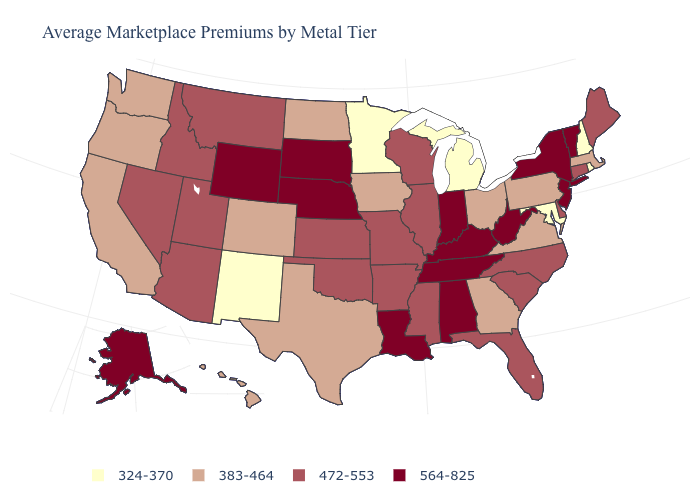Which states have the lowest value in the West?
Be succinct. New Mexico. Name the states that have a value in the range 383-464?
Short answer required. California, Colorado, Georgia, Hawaii, Iowa, Massachusetts, North Dakota, Ohio, Oregon, Pennsylvania, Texas, Virginia, Washington. Name the states that have a value in the range 383-464?
Give a very brief answer. California, Colorado, Georgia, Hawaii, Iowa, Massachusetts, North Dakota, Ohio, Oregon, Pennsylvania, Texas, Virginia, Washington. What is the value of Delaware?
Short answer required. 472-553. Name the states that have a value in the range 472-553?
Write a very short answer. Arizona, Arkansas, Connecticut, Delaware, Florida, Idaho, Illinois, Kansas, Maine, Mississippi, Missouri, Montana, Nevada, North Carolina, Oklahoma, South Carolina, Utah, Wisconsin. Does Virginia have a higher value than Montana?
Be succinct. No. Among the states that border Virginia , which have the lowest value?
Answer briefly. Maryland. How many symbols are there in the legend?
Answer briefly. 4. Does Pennsylvania have the lowest value in the USA?
Give a very brief answer. No. What is the value of Nevada?
Give a very brief answer. 472-553. Is the legend a continuous bar?
Concise answer only. No. What is the lowest value in the MidWest?
Answer briefly. 324-370. Does Tennessee have a lower value than Maryland?
Concise answer only. No. Name the states that have a value in the range 472-553?
Give a very brief answer. Arizona, Arkansas, Connecticut, Delaware, Florida, Idaho, Illinois, Kansas, Maine, Mississippi, Missouri, Montana, Nevada, North Carolina, Oklahoma, South Carolina, Utah, Wisconsin. Among the states that border North Dakota , does Minnesota have the lowest value?
Give a very brief answer. Yes. 